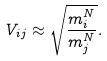Convert formula to latex. <formula><loc_0><loc_0><loc_500><loc_500>V _ { i j } \approx \sqrt { \frac { m ^ { N } _ { i } } { m ^ { N } _ { j } } } .</formula> 